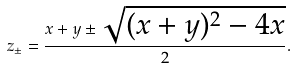Convert formula to latex. <formula><loc_0><loc_0><loc_500><loc_500>z _ { \pm } = \frac { x + y \pm \sqrt { ( x + y ) ^ { 2 } - 4 x } } { 2 } .</formula> 